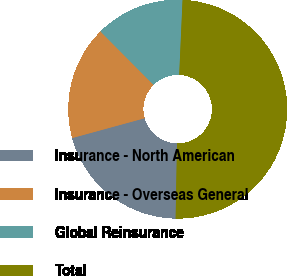Convert chart to OTSL. <chart><loc_0><loc_0><loc_500><loc_500><pie_chart><fcel>Insurance - North American<fcel>Insurance - Overseas General<fcel>Global Reinsurance<fcel>Total<nl><fcel>20.45%<fcel>16.8%<fcel>13.16%<fcel>49.59%<nl></chart> 